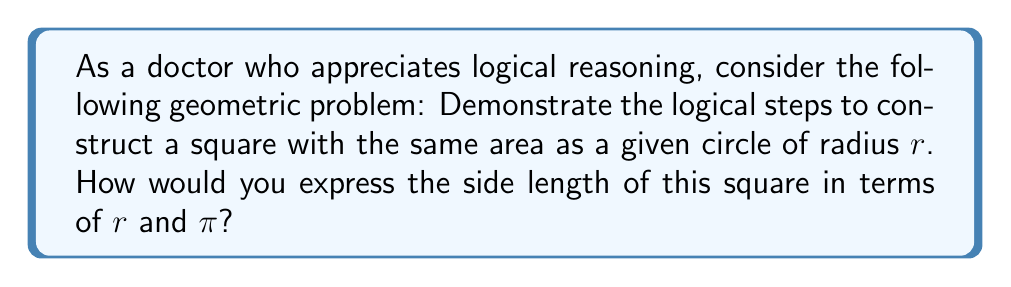What is the answer to this math problem? Let's approach this problem step-by-step, using logical reasoning:

1. Given: A circle with radius $r$.

2. Area of the circle:
   The area of a circle is given by the formula $A_c = \pi r^2$.

3. Goal: Construct a square with the same area.

4. Let the side length of the square be $s$.

5. Area of the square:
   The area of a square is given by $A_s = s^2$.

6. For the areas to be equal:
   $$A_c = A_s$$
   $$\pi r^2 = s^2$$

7. Solving for $s$:
   $$s^2 = \pi r^2$$
   $$s = \sqrt{\pi r^2}$$
   $$s = r\sqrt{\pi}$$

8. Construction:
   To construct this square, we need to:
   a) Draw a line segment of length $r$.
   b) Construct a right angle at one end of this segment.
   c) Along the perpendicular line, mark off a length of $\sqrt{\pi}$ times $r$.
   d) Complete the square using these two sides.

[asy]
unitsize(1cm);
pair A=(0,0), B=(3,0), C=(3,3*sqrt(pi)), D=(0,3*sqrt(pi));
draw(A--B--C--D--cycle);
label("$r$", (1.5,0), S);
label("$r\sqrt{\pi}$", (3,1.5*sqrt(pi)), E);
label("$s = r\sqrt{\pi}$", (1.5,3*sqrt(pi)), N);
[/asy]

This construction yields a square with side length $s = r\sqrt{\pi}$, which has the same area as the original circle.
Answer: $s = r\sqrt{\pi}$ 